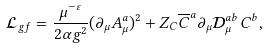Convert formula to latex. <formula><loc_0><loc_0><loc_500><loc_500>\mathcal { L } _ { g f } = \frac { \mu ^ { - \varepsilon } } { 2 \alpha g ^ { 2 } } ( \partial _ { \mu } A _ { \mu } ^ { a } ) ^ { 2 } + Z _ { C } \overline { C } ^ { a } \partial _ { \mu } \mathcal { D } _ { \mu } ^ { a b } C ^ { b } ,</formula> 